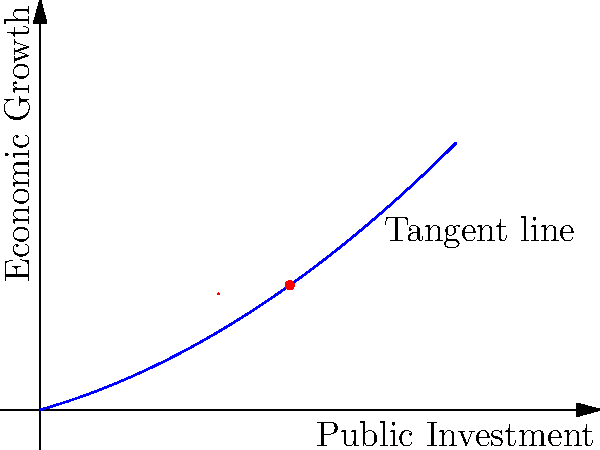The graph shows the relationship between public investment and economic growth. At a public investment level of 3, the tangent line is drawn. What is the slope of this tangent line, and what does it represent in the context of public investment and economic growth? To find the slope of the tangent line and interpret its meaning, we'll follow these steps:

1) The function representing the relationship appears to be of the form $f(x) = ax^2 + bx$, where $x$ is public investment and $f(x)$ is economic growth.

2) The derivative of this function is $f'(x) = 2ax + b$, which represents the rate of change of economic growth with respect to public investment.

3) The slope of the tangent line at any point is equal to the value of the derivative at that point.

4) From the graph, we can see that the tangent line is drawn at $x = 3$.

5) The slope of this tangent line appears to be $4.5$ (this can be calculated by counting grid squares or by using the function's derivative at $x = 3$).

6) In the context of public investment and economic growth, this slope represents the marginal effect of public investment on economic growth at that specific level of investment.

7) A positive slope of 4.5 indicates that at a public investment level of 3, each additional unit of public investment is associated with an increase of 4.5 units in economic growth.

8) This suggests that at this level of investment, increased public spending has a significant positive impact on economic growth, supporting the progressive campaign manager's advocacy for expansive government spending.
Answer: 4.5; marginal effect of public investment on economic growth 